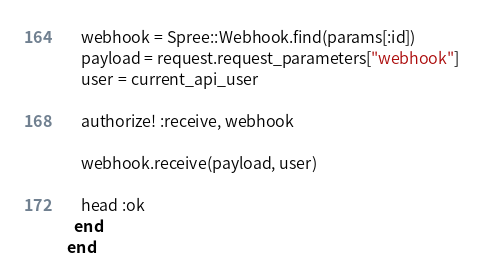<code> <loc_0><loc_0><loc_500><loc_500><_Ruby_>    webhook = Spree::Webhook.find(params[:id])
    payload = request.request_parameters["webhook"]
    user = current_api_user

    authorize! :receive, webhook

    webhook.receive(payload, user)

    head :ok
  end
end
</code> 